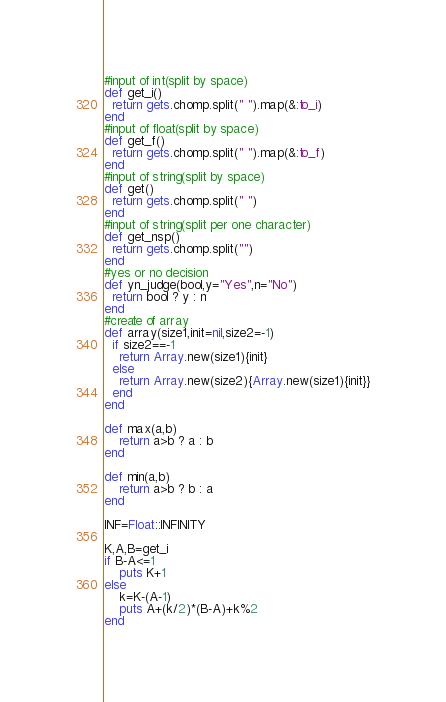Convert code to text. <code><loc_0><loc_0><loc_500><loc_500><_Ruby_>#input of int(split by space)
def get_i()
  return gets.chomp.split(" ").map(&:to_i)
end
#input of float(split by space)
def get_f()
  return gets.chomp.split(" ").map(&:to_f)
end
#input of string(split by space)
def get()
  return gets.chomp.split(" ")
end
#input of string(split per one character)
def get_nsp()
  return gets.chomp.split("")
end
#yes or no decision
def yn_judge(bool,y="Yes",n="No")
  return bool ? y : n 
end
#create of array
def array(size1,init=nil,size2=-1)
  if size2==-1
    return Array.new(size1){init}
  else
    return Array.new(size2){Array.new(size1){init}}
  end
end

def max(a,b)
    return a>b ? a : b
end

def min(a,b)
    return a>b ? b : a
end

INF=Float::INFINITY

K,A,B=get_i
if B-A<=1
    puts K+1
else
    k=K-(A-1)
    puts A+(k/2)*(B-A)+k%2
end</code> 